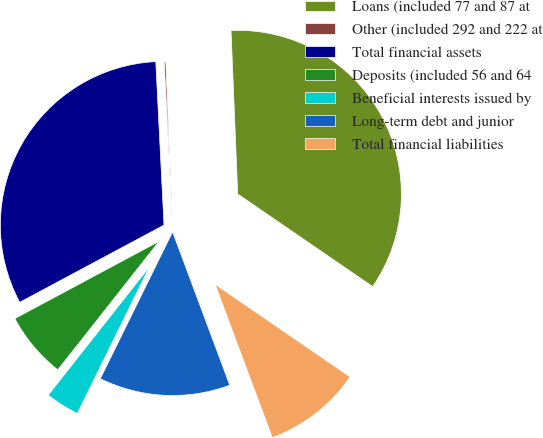Convert chart. <chart><loc_0><loc_0><loc_500><loc_500><pie_chart><fcel>Loans (included 77 and 87 at<fcel>Other (included 292 and 222 at<fcel>Total financial assets<fcel>Deposits (included 56 and 64<fcel>Beneficial interests issued by<fcel>Long-term debt and junior<fcel>Total financial liabilities<nl><fcel>35.22%<fcel>0.15%<fcel>32.02%<fcel>6.55%<fcel>3.35%<fcel>12.96%<fcel>9.75%<nl></chart> 